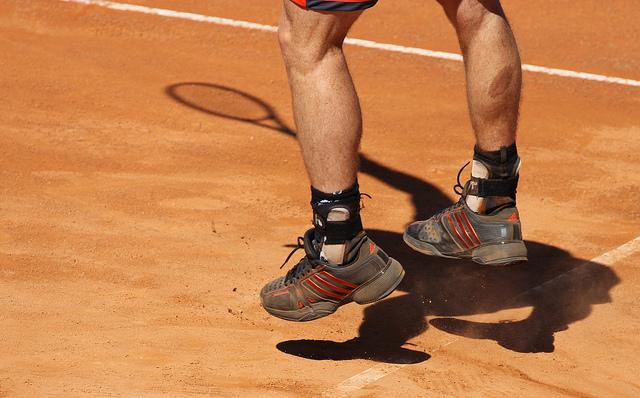What is in the shadow?
Be succinct. Tennis player. Is this person standing on the ground?
Give a very brief answer. No. What sport is being played?
Be succinct. Tennis. 